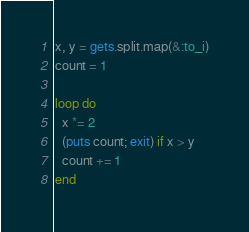Convert code to text. <code><loc_0><loc_0><loc_500><loc_500><_Ruby_>x, y = gets.split.map(&:to_i)
count = 1

loop do
  x *= 2
  (puts count; exit) if x > y
  count += 1
end</code> 